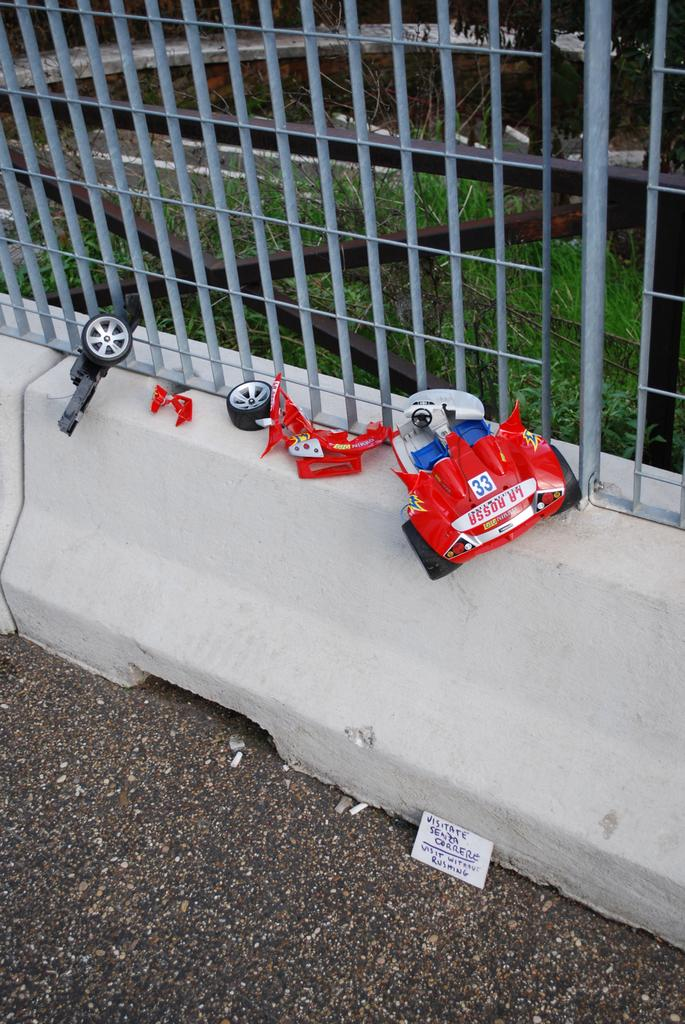What is the main subject of the image? The main subject of the image is a broken RC car. Where is the RC car located in the image? The RC car is on a fence. What can be seen in the background of the image? There is a grassland visible in the background of the image. How much money does the peace symbol in the image represent? There is no peace symbol or money present in the image; it features a broken RC car on a fence with a grassland background. 